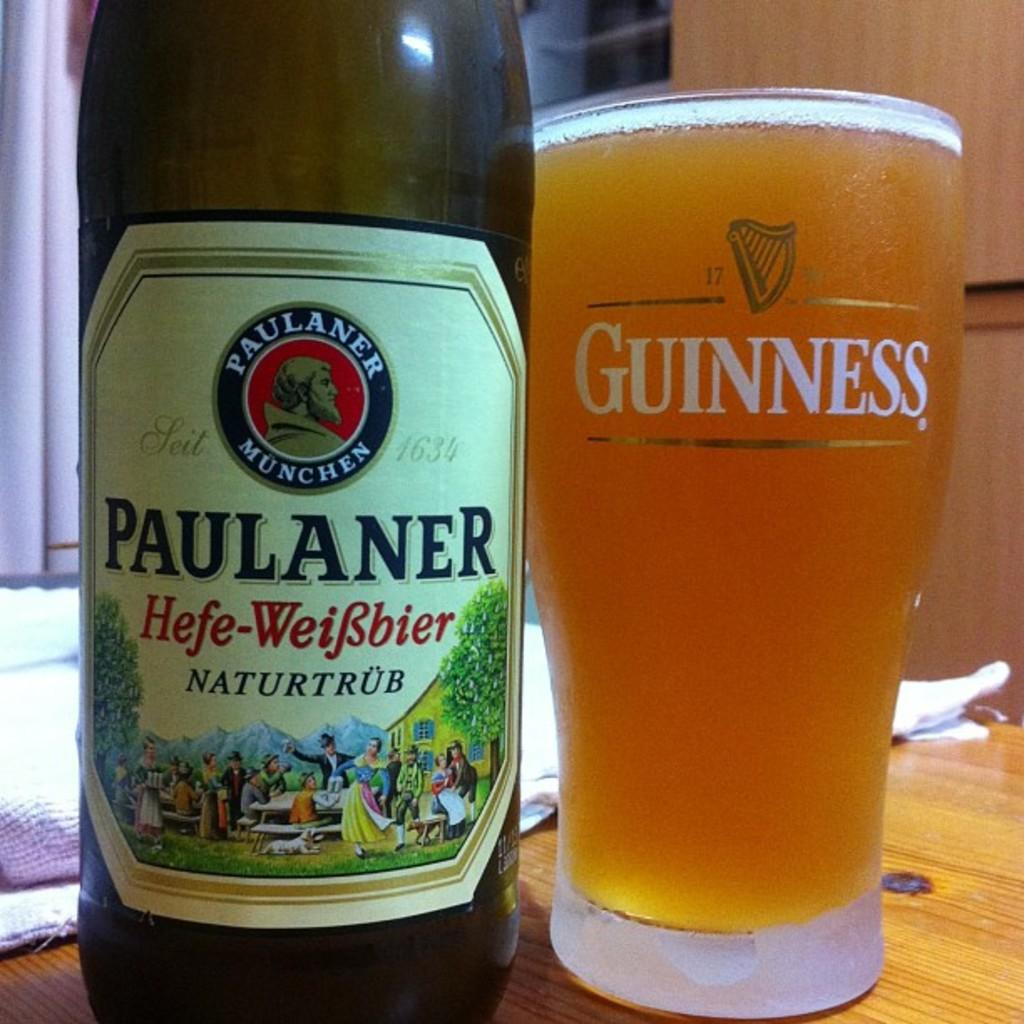<image>
Present a compact description of the photo's key features. A bottle of Paulaner is sitting next to a Guiness glass full of beer 